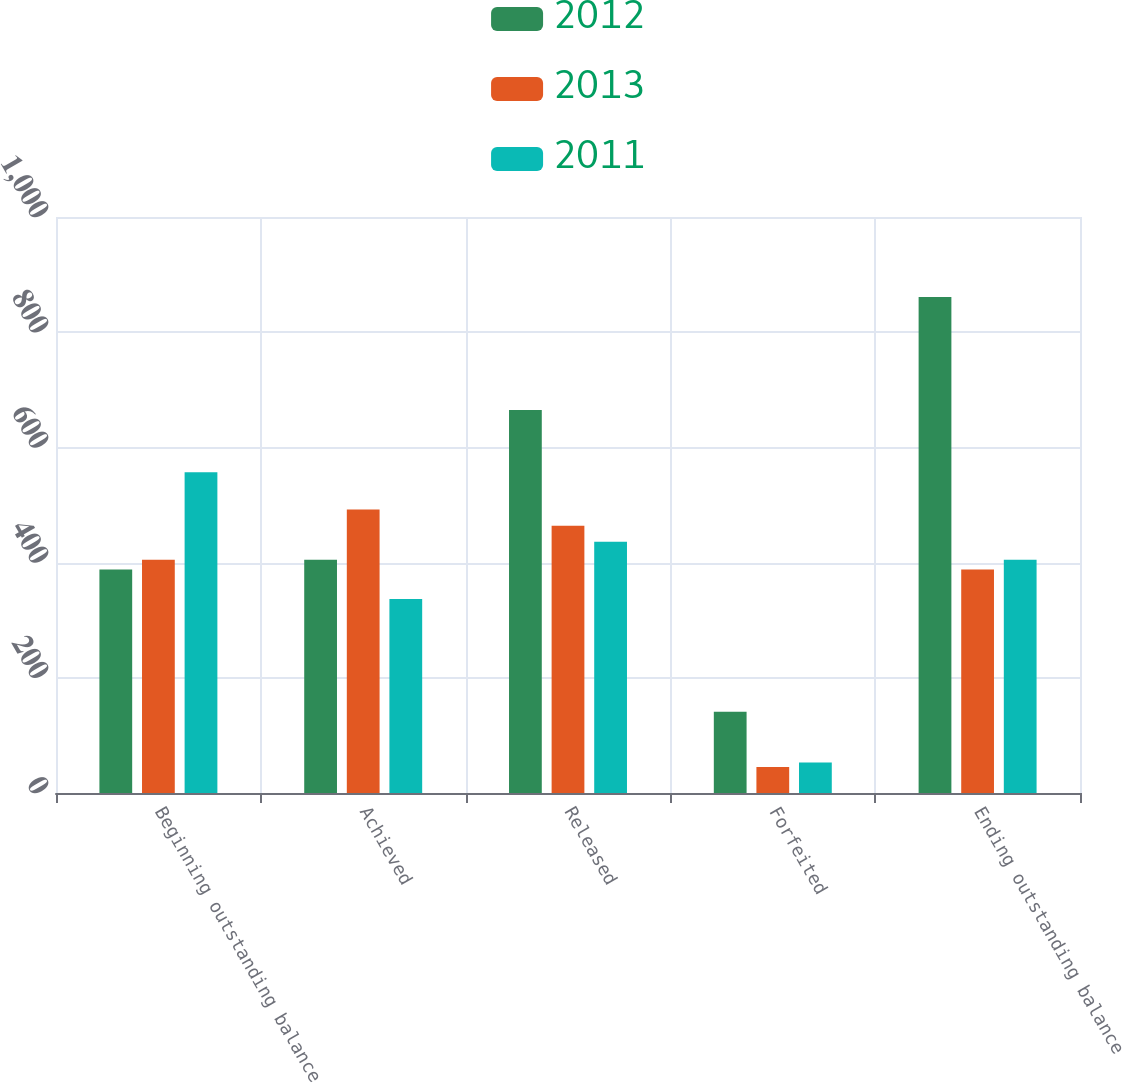<chart> <loc_0><loc_0><loc_500><loc_500><stacked_bar_chart><ecel><fcel>Beginning outstanding balance<fcel>Achieved<fcel>Released<fcel>Forfeited<fcel>Ending outstanding balance<nl><fcel>2012<fcel>388<fcel>405<fcel>665<fcel>141<fcel>861<nl><fcel>2013<fcel>405<fcel>492<fcel>464<fcel>45<fcel>388<nl><fcel>2011<fcel>557<fcel>337<fcel>436<fcel>53<fcel>405<nl></chart> 